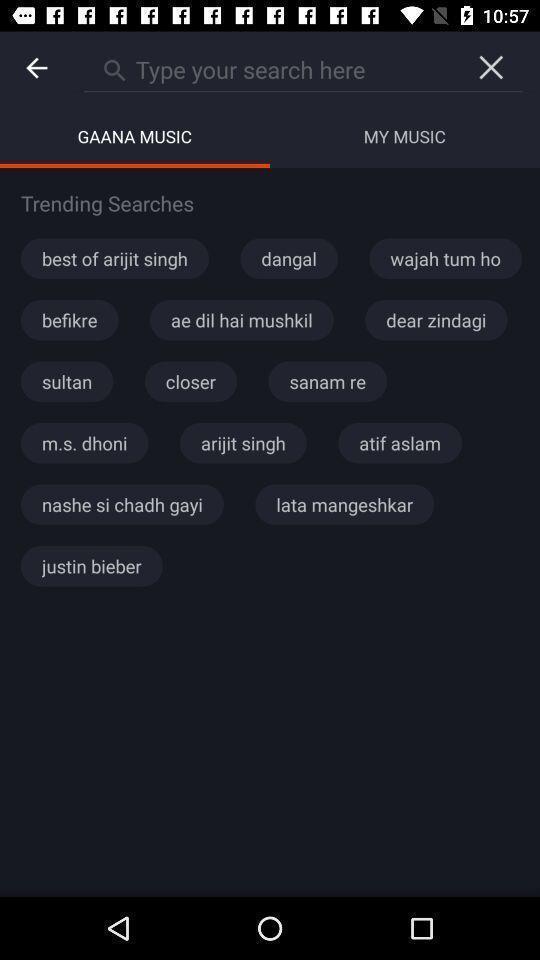Summarize the information in this screenshot. Search page of music app. 